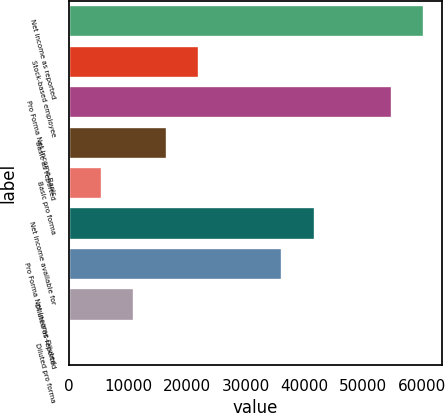Convert chart to OTSL. <chart><loc_0><loc_0><loc_500><loc_500><bar_chart><fcel>Net income as reported<fcel>Stock-based employee<fcel>Pro Forma Net Income-Basic<fcel>Basic as reported<fcel>Basic pro forma<fcel>Net income available for<fcel>Pro Forma Net Income-Diluted<fcel>Diluted as reported<fcel>Diluted pro forma<nl><fcel>60383.6<fcel>22115.3<fcel>54855<fcel>16586.7<fcel>5529.46<fcel>41698.6<fcel>36170<fcel>11058.1<fcel>0.84<nl></chart> 